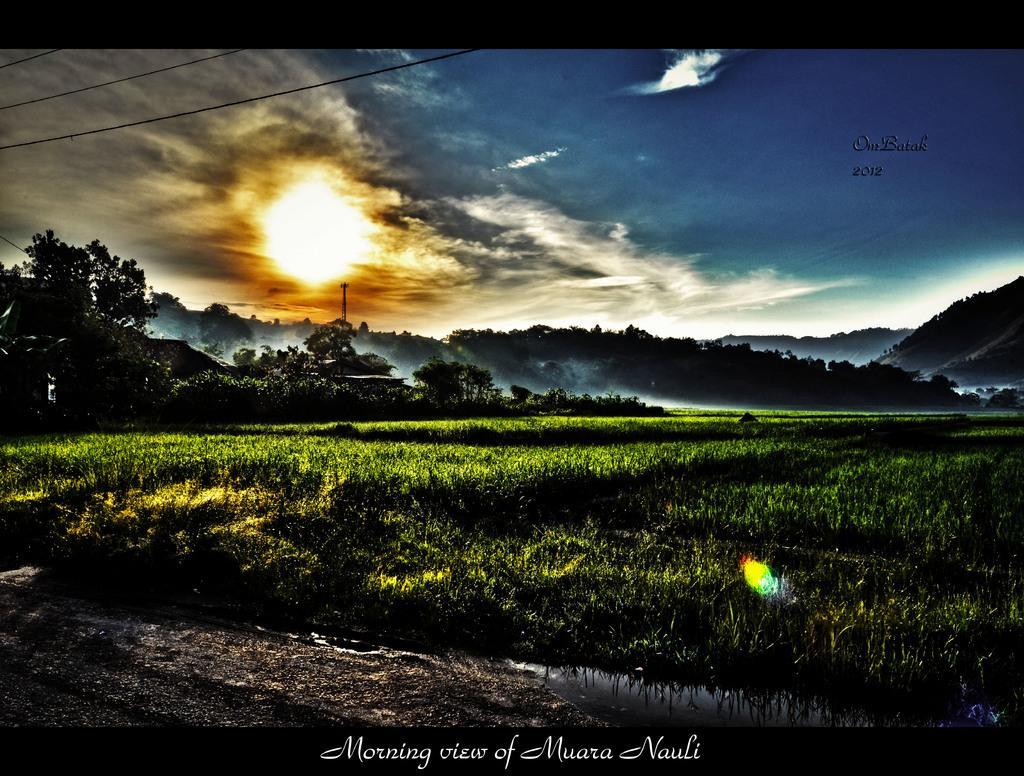Please provide a concise description of this image. In this picture I can see farm field. I can see water. I can see hills in the background. I can see trees. I can see clouds in the sky. 